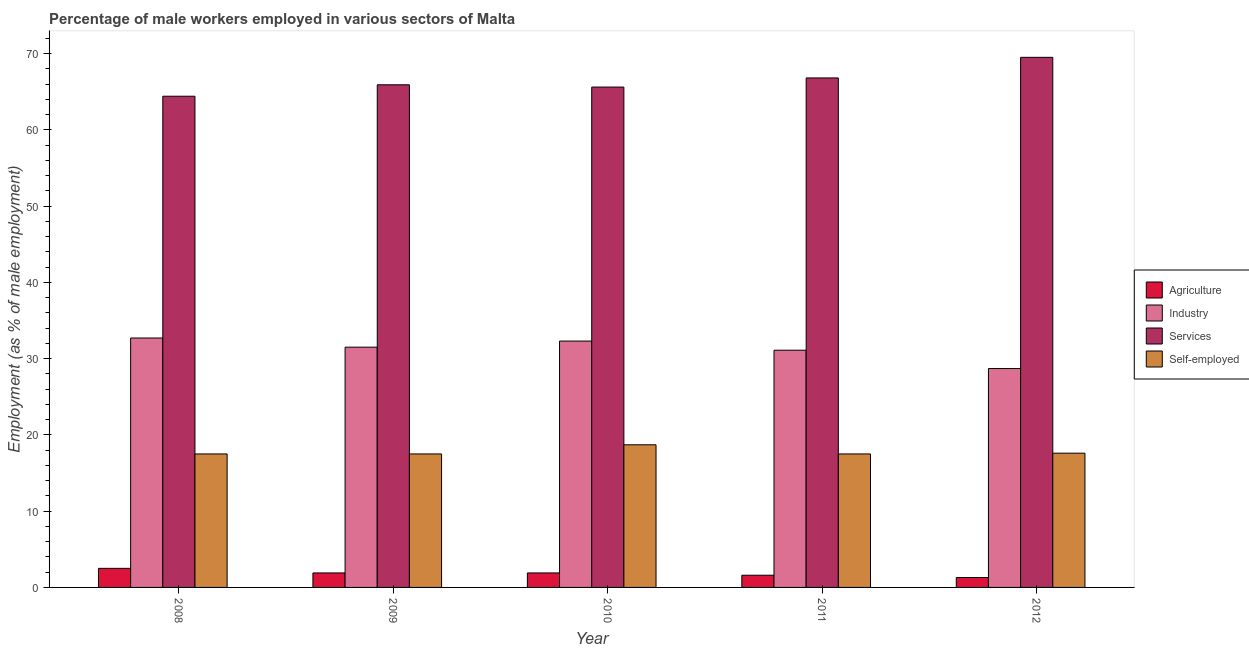Are the number of bars per tick equal to the number of legend labels?
Keep it short and to the point. Yes. How many bars are there on the 4th tick from the right?
Offer a terse response. 4. What is the label of the 3rd group of bars from the left?
Ensure brevity in your answer.  2010. In how many cases, is the number of bars for a given year not equal to the number of legend labels?
Offer a very short reply. 0. What is the percentage of male workers in industry in 2009?
Give a very brief answer. 31.5. Across all years, what is the maximum percentage of male workers in industry?
Provide a succinct answer. 32.7. Across all years, what is the minimum percentage of male workers in industry?
Offer a terse response. 28.7. In which year was the percentage of male workers in services maximum?
Your answer should be compact. 2012. What is the total percentage of self employed male workers in the graph?
Keep it short and to the point. 88.8. What is the difference between the percentage of male workers in agriculture in 2009 and that in 2010?
Your answer should be very brief. 0. What is the difference between the percentage of self employed male workers in 2012 and the percentage of male workers in services in 2009?
Make the answer very short. 0.1. What is the average percentage of male workers in industry per year?
Offer a very short reply. 31.26. In how many years, is the percentage of male workers in agriculture greater than 4 %?
Give a very brief answer. 0. What is the ratio of the percentage of self employed male workers in 2009 to that in 2010?
Ensure brevity in your answer.  0.94. What is the difference between the highest and the second highest percentage of male workers in agriculture?
Provide a short and direct response. 0.6. What is the difference between the highest and the lowest percentage of male workers in services?
Your answer should be compact. 5.1. Is the sum of the percentage of male workers in services in 2010 and 2011 greater than the maximum percentage of self employed male workers across all years?
Your answer should be compact. Yes. Is it the case that in every year, the sum of the percentage of male workers in agriculture and percentage of male workers in industry is greater than the sum of percentage of self employed male workers and percentage of male workers in services?
Provide a short and direct response. No. What does the 4th bar from the left in 2008 represents?
Make the answer very short. Self-employed. What does the 4th bar from the right in 2012 represents?
Offer a terse response. Agriculture. Is it the case that in every year, the sum of the percentage of male workers in agriculture and percentage of male workers in industry is greater than the percentage of male workers in services?
Keep it short and to the point. No. How many bars are there?
Give a very brief answer. 20. Are all the bars in the graph horizontal?
Your response must be concise. No. What is the difference between two consecutive major ticks on the Y-axis?
Your answer should be compact. 10. Does the graph contain any zero values?
Provide a succinct answer. No. Does the graph contain grids?
Offer a very short reply. No. How many legend labels are there?
Offer a terse response. 4. How are the legend labels stacked?
Provide a succinct answer. Vertical. What is the title of the graph?
Your response must be concise. Percentage of male workers employed in various sectors of Malta. What is the label or title of the Y-axis?
Your response must be concise. Employment (as % of male employment). What is the Employment (as % of male employment) in Industry in 2008?
Your response must be concise. 32.7. What is the Employment (as % of male employment) of Services in 2008?
Keep it short and to the point. 64.4. What is the Employment (as % of male employment) in Self-employed in 2008?
Your answer should be very brief. 17.5. What is the Employment (as % of male employment) of Agriculture in 2009?
Your answer should be very brief. 1.9. What is the Employment (as % of male employment) of Industry in 2009?
Offer a terse response. 31.5. What is the Employment (as % of male employment) in Services in 2009?
Provide a short and direct response. 65.9. What is the Employment (as % of male employment) in Self-employed in 2009?
Offer a very short reply. 17.5. What is the Employment (as % of male employment) of Agriculture in 2010?
Make the answer very short. 1.9. What is the Employment (as % of male employment) of Industry in 2010?
Your answer should be compact. 32.3. What is the Employment (as % of male employment) in Services in 2010?
Offer a terse response. 65.6. What is the Employment (as % of male employment) in Self-employed in 2010?
Ensure brevity in your answer.  18.7. What is the Employment (as % of male employment) in Agriculture in 2011?
Offer a very short reply. 1.6. What is the Employment (as % of male employment) in Industry in 2011?
Your answer should be very brief. 31.1. What is the Employment (as % of male employment) in Services in 2011?
Give a very brief answer. 66.8. What is the Employment (as % of male employment) of Self-employed in 2011?
Provide a short and direct response. 17.5. What is the Employment (as % of male employment) in Agriculture in 2012?
Offer a very short reply. 1.3. What is the Employment (as % of male employment) of Industry in 2012?
Your answer should be very brief. 28.7. What is the Employment (as % of male employment) in Services in 2012?
Offer a terse response. 69.5. What is the Employment (as % of male employment) in Self-employed in 2012?
Your answer should be very brief. 17.6. Across all years, what is the maximum Employment (as % of male employment) in Agriculture?
Keep it short and to the point. 2.5. Across all years, what is the maximum Employment (as % of male employment) of Industry?
Keep it short and to the point. 32.7. Across all years, what is the maximum Employment (as % of male employment) in Services?
Your answer should be compact. 69.5. Across all years, what is the maximum Employment (as % of male employment) of Self-employed?
Offer a terse response. 18.7. Across all years, what is the minimum Employment (as % of male employment) in Agriculture?
Keep it short and to the point. 1.3. Across all years, what is the minimum Employment (as % of male employment) of Industry?
Make the answer very short. 28.7. Across all years, what is the minimum Employment (as % of male employment) of Services?
Your response must be concise. 64.4. What is the total Employment (as % of male employment) of Industry in the graph?
Give a very brief answer. 156.3. What is the total Employment (as % of male employment) in Services in the graph?
Your response must be concise. 332.2. What is the total Employment (as % of male employment) of Self-employed in the graph?
Give a very brief answer. 88.8. What is the difference between the Employment (as % of male employment) of Industry in 2008 and that in 2009?
Ensure brevity in your answer.  1.2. What is the difference between the Employment (as % of male employment) of Agriculture in 2008 and that in 2010?
Make the answer very short. 0.6. What is the difference between the Employment (as % of male employment) in Services in 2008 and that in 2010?
Give a very brief answer. -1.2. What is the difference between the Employment (as % of male employment) in Self-employed in 2008 and that in 2010?
Provide a succinct answer. -1.2. What is the difference between the Employment (as % of male employment) of Industry in 2008 and that in 2011?
Your response must be concise. 1.6. What is the difference between the Employment (as % of male employment) of Services in 2008 and that in 2011?
Ensure brevity in your answer.  -2.4. What is the difference between the Employment (as % of male employment) of Industry in 2008 and that in 2012?
Offer a terse response. 4. What is the difference between the Employment (as % of male employment) of Industry in 2009 and that in 2010?
Provide a short and direct response. -0.8. What is the difference between the Employment (as % of male employment) of Self-employed in 2009 and that in 2010?
Provide a succinct answer. -1.2. What is the difference between the Employment (as % of male employment) of Services in 2009 and that in 2011?
Keep it short and to the point. -0.9. What is the difference between the Employment (as % of male employment) in Self-employed in 2009 and that in 2011?
Keep it short and to the point. 0. What is the difference between the Employment (as % of male employment) of Agriculture in 2010 and that in 2011?
Make the answer very short. 0.3. What is the difference between the Employment (as % of male employment) of Industry in 2010 and that in 2011?
Provide a succinct answer. 1.2. What is the difference between the Employment (as % of male employment) of Services in 2010 and that in 2011?
Provide a succinct answer. -1.2. What is the difference between the Employment (as % of male employment) of Self-employed in 2010 and that in 2011?
Keep it short and to the point. 1.2. What is the difference between the Employment (as % of male employment) of Agriculture in 2010 and that in 2012?
Your answer should be compact. 0.6. What is the difference between the Employment (as % of male employment) of Agriculture in 2011 and that in 2012?
Ensure brevity in your answer.  0.3. What is the difference between the Employment (as % of male employment) in Self-employed in 2011 and that in 2012?
Your response must be concise. -0.1. What is the difference between the Employment (as % of male employment) of Agriculture in 2008 and the Employment (as % of male employment) of Industry in 2009?
Provide a short and direct response. -29. What is the difference between the Employment (as % of male employment) of Agriculture in 2008 and the Employment (as % of male employment) of Services in 2009?
Make the answer very short. -63.4. What is the difference between the Employment (as % of male employment) of Industry in 2008 and the Employment (as % of male employment) of Services in 2009?
Make the answer very short. -33.2. What is the difference between the Employment (as % of male employment) of Industry in 2008 and the Employment (as % of male employment) of Self-employed in 2009?
Provide a short and direct response. 15.2. What is the difference between the Employment (as % of male employment) in Services in 2008 and the Employment (as % of male employment) in Self-employed in 2009?
Keep it short and to the point. 46.9. What is the difference between the Employment (as % of male employment) of Agriculture in 2008 and the Employment (as % of male employment) of Industry in 2010?
Give a very brief answer. -29.8. What is the difference between the Employment (as % of male employment) in Agriculture in 2008 and the Employment (as % of male employment) in Services in 2010?
Provide a short and direct response. -63.1. What is the difference between the Employment (as % of male employment) in Agriculture in 2008 and the Employment (as % of male employment) in Self-employed in 2010?
Provide a short and direct response. -16.2. What is the difference between the Employment (as % of male employment) in Industry in 2008 and the Employment (as % of male employment) in Services in 2010?
Provide a succinct answer. -32.9. What is the difference between the Employment (as % of male employment) of Industry in 2008 and the Employment (as % of male employment) of Self-employed in 2010?
Your answer should be compact. 14. What is the difference between the Employment (as % of male employment) in Services in 2008 and the Employment (as % of male employment) in Self-employed in 2010?
Ensure brevity in your answer.  45.7. What is the difference between the Employment (as % of male employment) in Agriculture in 2008 and the Employment (as % of male employment) in Industry in 2011?
Provide a succinct answer. -28.6. What is the difference between the Employment (as % of male employment) in Agriculture in 2008 and the Employment (as % of male employment) in Services in 2011?
Give a very brief answer. -64.3. What is the difference between the Employment (as % of male employment) of Agriculture in 2008 and the Employment (as % of male employment) of Self-employed in 2011?
Your answer should be very brief. -15. What is the difference between the Employment (as % of male employment) of Industry in 2008 and the Employment (as % of male employment) of Services in 2011?
Keep it short and to the point. -34.1. What is the difference between the Employment (as % of male employment) of Services in 2008 and the Employment (as % of male employment) of Self-employed in 2011?
Offer a terse response. 46.9. What is the difference between the Employment (as % of male employment) of Agriculture in 2008 and the Employment (as % of male employment) of Industry in 2012?
Provide a short and direct response. -26.2. What is the difference between the Employment (as % of male employment) in Agriculture in 2008 and the Employment (as % of male employment) in Services in 2012?
Your answer should be very brief. -67. What is the difference between the Employment (as % of male employment) of Agriculture in 2008 and the Employment (as % of male employment) of Self-employed in 2012?
Your answer should be very brief. -15.1. What is the difference between the Employment (as % of male employment) in Industry in 2008 and the Employment (as % of male employment) in Services in 2012?
Your response must be concise. -36.8. What is the difference between the Employment (as % of male employment) of Industry in 2008 and the Employment (as % of male employment) of Self-employed in 2012?
Your answer should be compact. 15.1. What is the difference between the Employment (as % of male employment) in Services in 2008 and the Employment (as % of male employment) in Self-employed in 2012?
Give a very brief answer. 46.8. What is the difference between the Employment (as % of male employment) in Agriculture in 2009 and the Employment (as % of male employment) in Industry in 2010?
Provide a short and direct response. -30.4. What is the difference between the Employment (as % of male employment) in Agriculture in 2009 and the Employment (as % of male employment) in Services in 2010?
Keep it short and to the point. -63.7. What is the difference between the Employment (as % of male employment) of Agriculture in 2009 and the Employment (as % of male employment) of Self-employed in 2010?
Provide a short and direct response. -16.8. What is the difference between the Employment (as % of male employment) of Industry in 2009 and the Employment (as % of male employment) of Services in 2010?
Give a very brief answer. -34.1. What is the difference between the Employment (as % of male employment) of Industry in 2009 and the Employment (as % of male employment) of Self-employed in 2010?
Your answer should be compact. 12.8. What is the difference between the Employment (as % of male employment) of Services in 2009 and the Employment (as % of male employment) of Self-employed in 2010?
Give a very brief answer. 47.2. What is the difference between the Employment (as % of male employment) in Agriculture in 2009 and the Employment (as % of male employment) in Industry in 2011?
Provide a succinct answer. -29.2. What is the difference between the Employment (as % of male employment) of Agriculture in 2009 and the Employment (as % of male employment) of Services in 2011?
Provide a succinct answer. -64.9. What is the difference between the Employment (as % of male employment) in Agriculture in 2009 and the Employment (as % of male employment) in Self-employed in 2011?
Your response must be concise. -15.6. What is the difference between the Employment (as % of male employment) in Industry in 2009 and the Employment (as % of male employment) in Services in 2011?
Offer a very short reply. -35.3. What is the difference between the Employment (as % of male employment) of Services in 2009 and the Employment (as % of male employment) of Self-employed in 2011?
Your response must be concise. 48.4. What is the difference between the Employment (as % of male employment) of Agriculture in 2009 and the Employment (as % of male employment) of Industry in 2012?
Offer a terse response. -26.8. What is the difference between the Employment (as % of male employment) in Agriculture in 2009 and the Employment (as % of male employment) in Services in 2012?
Ensure brevity in your answer.  -67.6. What is the difference between the Employment (as % of male employment) in Agriculture in 2009 and the Employment (as % of male employment) in Self-employed in 2012?
Make the answer very short. -15.7. What is the difference between the Employment (as % of male employment) of Industry in 2009 and the Employment (as % of male employment) of Services in 2012?
Your answer should be very brief. -38. What is the difference between the Employment (as % of male employment) in Services in 2009 and the Employment (as % of male employment) in Self-employed in 2012?
Give a very brief answer. 48.3. What is the difference between the Employment (as % of male employment) of Agriculture in 2010 and the Employment (as % of male employment) of Industry in 2011?
Your answer should be very brief. -29.2. What is the difference between the Employment (as % of male employment) of Agriculture in 2010 and the Employment (as % of male employment) of Services in 2011?
Offer a very short reply. -64.9. What is the difference between the Employment (as % of male employment) in Agriculture in 2010 and the Employment (as % of male employment) in Self-employed in 2011?
Keep it short and to the point. -15.6. What is the difference between the Employment (as % of male employment) of Industry in 2010 and the Employment (as % of male employment) of Services in 2011?
Offer a terse response. -34.5. What is the difference between the Employment (as % of male employment) of Industry in 2010 and the Employment (as % of male employment) of Self-employed in 2011?
Give a very brief answer. 14.8. What is the difference between the Employment (as % of male employment) of Services in 2010 and the Employment (as % of male employment) of Self-employed in 2011?
Give a very brief answer. 48.1. What is the difference between the Employment (as % of male employment) in Agriculture in 2010 and the Employment (as % of male employment) in Industry in 2012?
Provide a succinct answer. -26.8. What is the difference between the Employment (as % of male employment) in Agriculture in 2010 and the Employment (as % of male employment) in Services in 2012?
Your answer should be compact. -67.6. What is the difference between the Employment (as % of male employment) of Agriculture in 2010 and the Employment (as % of male employment) of Self-employed in 2012?
Your answer should be compact. -15.7. What is the difference between the Employment (as % of male employment) of Industry in 2010 and the Employment (as % of male employment) of Services in 2012?
Ensure brevity in your answer.  -37.2. What is the difference between the Employment (as % of male employment) in Industry in 2010 and the Employment (as % of male employment) in Self-employed in 2012?
Ensure brevity in your answer.  14.7. What is the difference between the Employment (as % of male employment) of Agriculture in 2011 and the Employment (as % of male employment) of Industry in 2012?
Provide a short and direct response. -27.1. What is the difference between the Employment (as % of male employment) in Agriculture in 2011 and the Employment (as % of male employment) in Services in 2012?
Provide a short and direct response. -67.9. What is the difference between the Employment (as % of male employment) of Agriculture in 2011 and the Employment (as % of male employment) of Self-employed in 2012?
Your response must be concise. -16. What is the difference between the Employment (as % of male employment) in Industry in 2011 and the Employment (as % of male employment) in Services in 2012?
Offer a very short reply. -38.4. What is the difference between the Employment (as % of male employment) in Services in 2011 and the Employment (as % of male employment) in Self-employed in 2012?
Your answer should be compact. 49.2. What is the average Employment (as % of male employment) of Agriculture per year?
Offer a terse response. 1.84. What is the average Employment (as % of male employment) of Industry per year?
Make the answer very short. 31.26. What is the average Employment (as % of male employment) of Services per year?
Provide a short and direct response. 66.44. What is the average Employment (as % of male employment) in Self-employed per year?
Your answer should be compact. 17.76. In the year 2008, what is the difference between the Employment (as % of male employment) of Agriculture and Employment (as % of male employment) of Industry?
Provide a succinct answer. -30.2. In the year 2008, what is the difference between the Employment (as % of male employment) in Agriculture and Employment (as % of male employment) in Services?
Offer a terse response. -61.9. In the year 2008, what is the difference between the Employment (as % of male employment) of Agriculture and Employment (as % of male employment) of Self-employed?
Your answer should be compact. -15. In the year 2008, what is the difference between the Employment (as % of male employment) in Industry and Employment (as % of male employment) in Services?
Ensure brevity in your answer.  -31.7. In the year 2008, what is the difference between the Employment (as % of male employment) of Services and Employment (as % of male employment) of Self-employed?
Your answer should be very brief. 46.9. In the year 2009, what is the difference between the Employment (as % of male employment) in Agriculture and Employment (as % of male employment) in Industry?
Your response must be concise. -29.6. In the year 2009, what is the difference between the Employment (as % of male employment) in Agriculture and Employment (as % of male employment) in Services?
Provide a succinct answer. -64. In the year 2009, what is the difference between the Employment (as % of male employment) in Agriculture and Employment (as % of male employment) in Self-employed?
Provide a short and direct response. -15.6. In the year 2009, what is the difference between the Employment (as % of male employment) in Industry and Employment (as % of male employment) in Services?
Your answer should be compact. -34.4. In the year 2009, what is the difference between the Employment (as % of male employment) in Services and Employment (as % of male employment) in Self-employed?
Ensure brevity in your answer.  48.4. In the year 2010, what is the difference between the Employment (as % of male employment) of Agriculture and Employment (as % of male employment) of Industry?
Your answer should be compact. -30.4. In the year 2010, what is the difference between the Employment (as % of male employment) of Agriculture and Employment (as % of male employment) of Services?
Give a very brief answer. -63.7. In the year 2010, what is the difference between the Employment (as % of male employment) of Agriculture and Employment (as % of male employment) of Self-employed?
Give a very brief answer. -16.8. In the year 2010, what is the difference between the Employment (as % of male employment) in Industry and Employment (as % of male employment) in Services?
Make the answer very short. -33.3. In the year 2010, what is the difference between the Employment (as % of male employment) in Industry and Employment (as % of male employment) in Self-employed?
Keep it short and to the point. 13.6. In the year 2010, what is the difference between the Employment (as % of male employment) in Services and Employment (as % of male employment) in Self-employed?
Your answer should be compact. 46.9. In the year 2011, what is the difference between the Employment (as % of male employment) in Agriculture and Employment (as % of male employment) in Industry?
Give a very brief answer. -29.5. In the year 2011, what is the difference between the Employment (as % of male employment) of Agriculture and Employment (as % of male employment) of Services?
Ensure brevity in your answer.  -65.2. In the year 2011, what is the difference between the Employment (as % of male employment) in Agriculture and Employment (as % of male employment) in Self-employed?
Give a very brief answer. -15.9. In the year 2011, what is the difference between the Employment (as % of male employment) of Industry and Employment (as % of male employment) of Services?
Your response must be concise. -35.7. In the year 2011, what is the difference between the Employment (as % of male employment) in Services and Employment (as % of male employment) in Self-employed?
Offer a very short reply. 49.3. In the year 2012, what is the difference between the Employment (as % of male employment) of Agriculture and Employment (as % of male employment) of Industry?
Ensure brevity in your answer.  -27.4. In the year 2012, what is the difference between the Employment (as % of male employment) in Agriculture and Employment (as % of male employment) in Services?
Your answer should be compact. -68.2. In the year 2012, what is the difference between the Employment (as % of male employment) in Agriculture and Employment (as % of male employment) in Self-employed?
Keep it short and to the point. -16.3. In the year 2012, what is the difference between the Employment (as % of male employment) of Industry and Employment (as % of male employment) of Services?
Your answer should be compact. -40.8. In the year 2012, what is the difference between the Employment (as % of male employment) in Services and Employment (as % of male employment) in Self-employed?
Your answer should be compact. 51.9. What is the ratio of the Employment (as % of male employment) in Agriculture in 2008 to that in 2009?
Your answer should be very brief. 1.32. What is the ratio of the Employment (as % of male employment) in Industry in 2008 to that in 2009?
Make the answer very short. 1.04. What is the ratio of the Employment (as % of male employment) of Services in 2008 to that in 2009?
Give a very brief answer. 0.98. What is the ratio of the Employment (as % of male employment) of Self-employed in 2008 to that in 2009?
Provide a short and direct response. 1. What is the ratio of the Employment (as % of male employment) in Agriculture in 2008 to that in 2010?
Provide a short and direct response. 1.32. What is the ratio of the Employment (as % of male employment) of Industry in 2008 to that in 2010?
Give a very brief answer. 1.01. What is the ratio of the Employment (as % of male employment) of Services in 2008 to that in 2010?
Make the answer very short. 0.98. What is the ratio of the Employment (as % of male employment) of Self-employed in 2008 to that in 2010?
Your answer should be compact. 0.94. What is the ratio of the Employment (as % of male employment) in Agriculture in 2008 to that in 2011?
Offer a very short reply. 1.56. What is the ratio of the Employment (as % of male employment) in Industry in 2008 to that in 2011?
Your answer should be compact. 1.05. What is the ratio of the Employment (as % of male employment) of Services in 2008 to that in 2011?
Give a very brief answer. 0.96. What is the ratio of the Employment (as % of male employment) in Self-employed in 2008 to that in 2011?
Provide a short and direct response. 1. What is the ratio of the Employment (as % of male employment) of Agriculture in 2008 to that in 2012?
Make the answer very short. 1.92. What is the ratio of the Employment (as % of male employment) in Industry in 2008 to that in 2012?
Your response must be concise. 1.14. What is the ratio of the Employment (as % of male employment) in Services in 2008 to that in 2012?
Your answer should be very brief. 0.93. What is the ratio of the Employment (as % of male employment) in Agriculture in 2009 to that in 2010?
Offer a very short reply. 1. What is the ratio of the Employment (as % of male employment) of Industry in 2009 to that in 2010?
Give a very brief answer. 0.98. What is the ratio of the Employment (as % of male employment) in Services in 2009 to that in 2010?
Your answer should be very brief. 1. What is the ratio of the Employment (as % of male employment) of Self-employed in 2009 to that in 2010?
Offer a terse response. 0.94. What is the ratio of the Employment (as % of male employment) of Agriculture in 2009 to that in 2011?
Make the answer very short. 1.19. What is the ratio of the Employment (as % of male employment) of Industry in 2009 to that in 2011?
Your answer should be very brief. 1.01. What is the ratio of the Employment (as % of male employment) in Services in 2009 to that in 2011?
Give a very brief answer. 0.99. What is the ratio of the Employment (as % of male employment) of Self-employed in 2009 to that in 2011?
Your answer should be very brief. 1. What is the ratio of the Employment (as % of male employment) in Agriculture in 2009 to that in 2012?
Provide a short and direct response. 1.46. What is the ratio of the Employment (as % of male employment) in Industry in 2009 to that in 2012?
Keep it short and to the point. 1.1. What is the ratio of the Employment (as % of male employment) in Services in 2009 to that in 2012?
Your response must be concise. 0.95. What is the ratio of the Employment (as % of male employment) of Agriculture in 2010 to that in 2011?
Your answer should be very brief. 1.19. What is the ratio of the Employment (as % of male employment) in Industry in 2010 to that in 2011?
Offer a terse response. 1.04. What is the ratio of the Employment (as % of male employment) of Services in 2010 to that in 2011?
Provide a short and direct response. 0.98. What is the ratio of the Employment (as % of male employment) of Self-employed in 2010 to that in 2011?
Provide a short and direct response. 1.07. What is the ratio of the Employment (as % of male employment) of Agriculture in 2010 to that in 2012?
Your answer should be compact. 1.46. What is the ratio of the Employment (as % of male employment) of Industry in 2010 to that in 2012?
Provide a short and direct response. 1.13. What is the ratio of the Employment (as % of male employment) in Services in 2010 to that in 2012?
Your answer should be very brief. 0.94. What is the ratio of the Employment (as % of male employment) of Agriculture in 2011 to that in 2012?
Make the answer very short. 1.23. What is the ratio of the Employment (as % of male employment) in Industry in 2011 to that in 2012?
Make the answer very short. 1.08. What is the ratio of the Employment (as % of male employment) of Services in 2011 to that in 2012?
Your response must be concise. 0.96. What is the difference between the highest and the second highest Employment (as % of male employment) in Agriculture?
Make the answer very short. 0.6. What is the difference between the highest and the second highest Employment (as % of male employment) in Industry?
Your response must be concise. 0.4. What is the difference between the highest and the second highest Employment (as % of male employment) of Services?
Provide a short and direct response. 2.7. What is the difference between the highest and the lowest Employment (as % of male employment) in Agriculture?
Your response must be concise. 1.2. What is the difference between the highest and the lowest Employment (as % of male employment) in Self-employed?
Offer a very short reply. 1.2. 